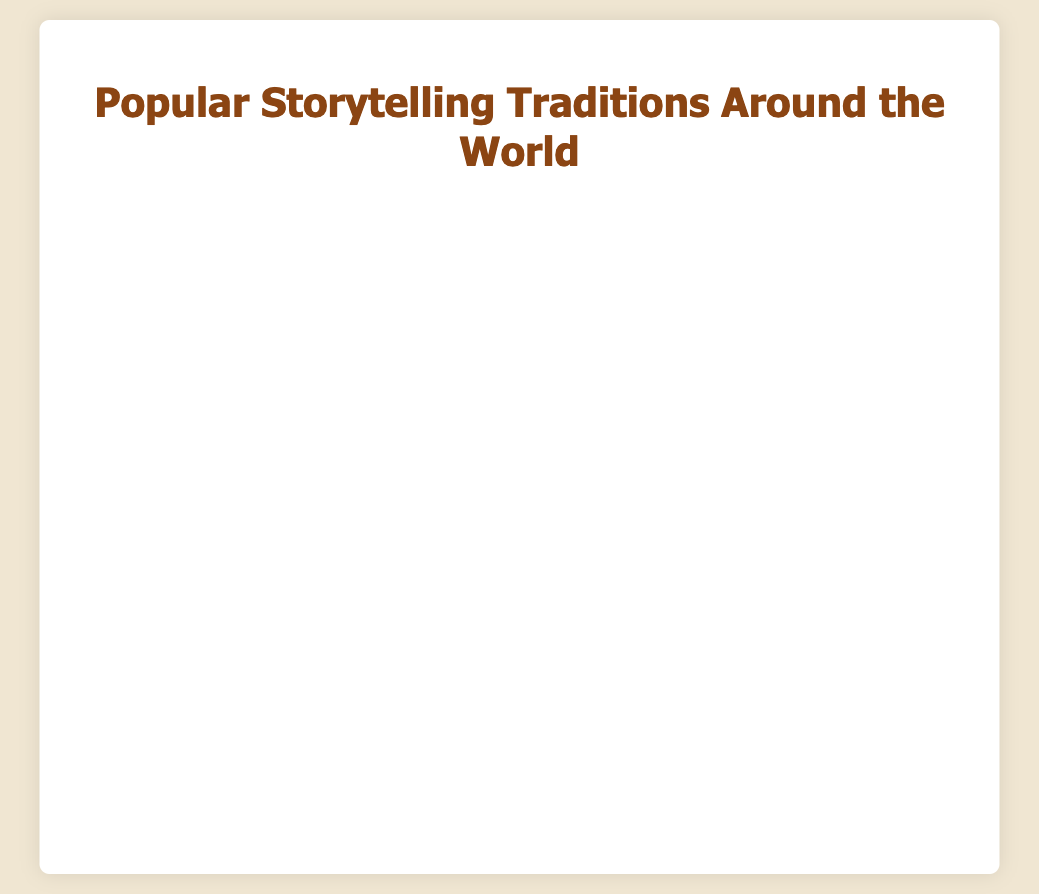Which storytelling tradition has the highest popularity score? By looking at the figure, we find the bar that extends the longest to the right, which represents the highest score. The "Panchatantra" tradition in India has the highest popularity score.
Answer: Panchatantra Which storytelling tradition has the lowest popularity score? By identifying the shortest bar in the chart, we can see that the "Seanchai" tradition in Ireland has the lowest score.
Answer: Seanchai How much higher is the popularity score of "Panchatantra" compared to "Seanchai"? The popularity score of "Panchatantra" is 90 while "Seanchai" has 78. The difference is calculated as 90 - 78.
Answer: 12 What is the average popularity score of all the storytelling traditions? To find the average, sum all the popularity scores, which are 85, 78, 90, 82, 88, 80, 87, 83, 79, 84. The sum is 836. There are 10 traditions, so the average is 836 / 10.
Answer: 83.6 Which country has the third highest popularity score for its storytelling tradition? The third longest bar is for "Truyện Cổ Tích" in Vietnam with a score of 87, following India (90) and Norway (88).
Answer: Vietnam What is the combined popularity score for "Rakugo" and "Aboriginal Dreamtime Stories"? "Rakugo" has a score of 85 and "Aboriginal Dreamtime Stories" has a score of 84. The combined score is 85 + 84.
Answer: 169 Rank the storytelling traditions based on their popularity scores from highest to lowest. Comparing the lengths of all bars from longest to shortest: Panchatantra (India), Asbjørnsen and Moe Folktales (Norway), Truyện Cổ Tích (Vietnam), Rakugo (Japan), Aboriginal Dreamtime Stories (Australia), Byliny (Russia), Anansi Stories (Ghana), Día de los Muertos Stories (Mexico), Tall Tales (United States), Seanchai (Ireland).
Answer: India, Norway, Vietnam, Japan, Australia, Russia, Ghana, Mexico, United States, Ireland Is "Byliny" more popular than "Día de los Muertos Stories"? By comparing the respective lengths of the bars representing these traditions, "Byliny" (83) extends farther to the right than "Día de los Muertos Stories" (80).
Answer: Yes Which tradition has a popularity score closest to the average popularity score? The average popularity score calculated earlier is 83.6. Comparing the scores, "Byliny" from Russia, with a score of 83, is the closest to the average.
Answer: Byliny 